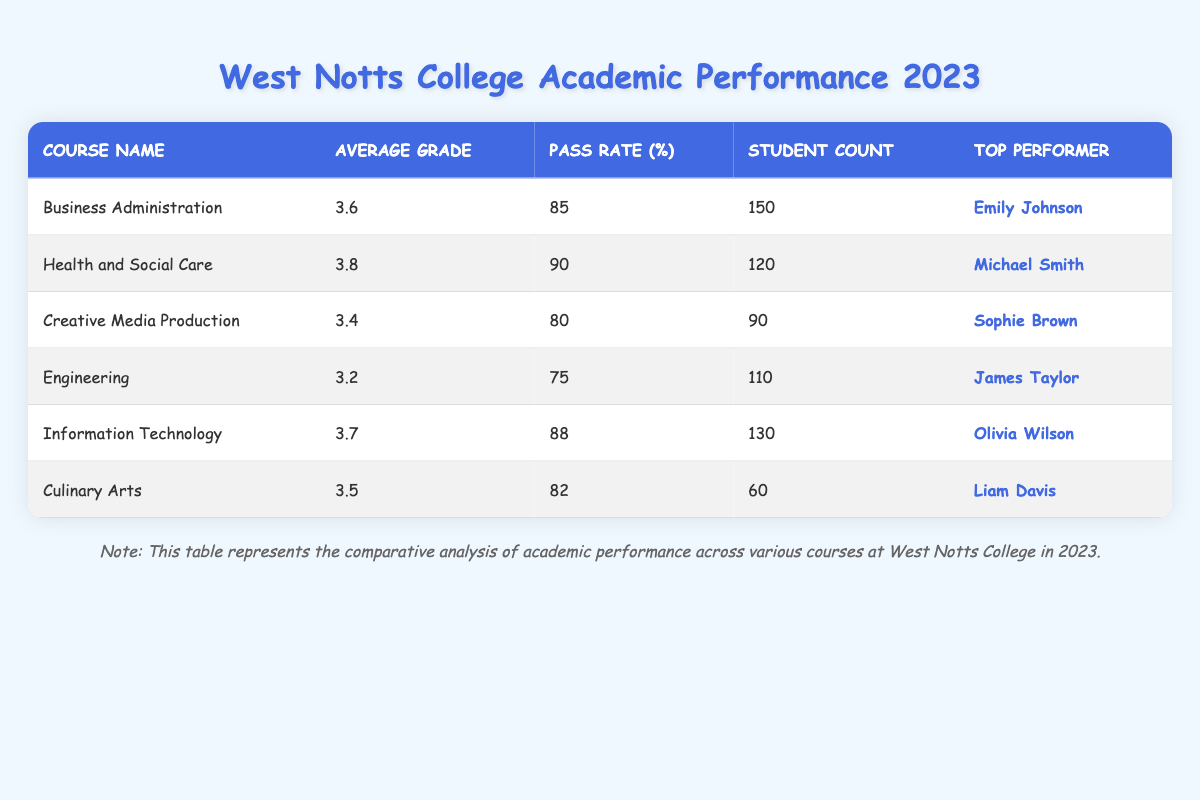What is the average grade for the Health and Social Care course? The average grade for Health and Social Care can be found in the table under the "Average Grade" column for that specific course, which is 3.8.
Answer: 3.8 Which course has the highest pass rate? The pass rate for each course is indicated in the "Pass Rate (%)" column. By comparing the values, Health and Social Care has the highest pass rate at 90%.
Answer: Health and Social Care How many students are enrolled in Culinary Arts? The student count for Culinary Arts is listed in the "Student Count" column, which shows there are 60 students enrolled in that course.
Answer: 60 What is the difference in average grades between Information Technology and Engineering? The average grade for Information Technology is 3.7, and for Engineering, it is 3.2. To find the difference, subtract 3.2 from 3.7, which equals 0.5.
Answer: 0.5 Is it true that the average grade for Business Administration is higher than that of Creative Media Production? The average grade for Business Administration is 3.6, while for Creative Media Production it is 3.4. Since 3.6 is greater than 3.4, the statement is true.
Answer: Yes How many total students are enrolled across all courses? To find the total number of students, add the student counts from each course: 150 (Business Administration) + 120 (Health and Social Care) + 90 (Creative Media Production) + 110 (Engineering) + 130 (Information Technology) + 60 (Culinary Arts) = 660 students in total.
Answer: 660 Who is the top performer in Engineering? The top performer in Engineering is identified in the "Top Performer" column, which shows James Taylor as the top student for that course.
Answer: James Taylor Which course has the lowest average grade and what is that grade? The average grades listed show that Engineering has the lowest average grade at 3.2, as it is lower than the other courses listed.
Answer: 3.2 What is the average pass rate of all courses combined? The average pass rate can be calculated by adding the pass rates of all courses: 85 + 90 + 80 + 75 + 88 + 82 = 500, then dividing this sum by the number of courses (6), resulting in an average pass rate of approximately 83.33%.
Answer: 83.33 